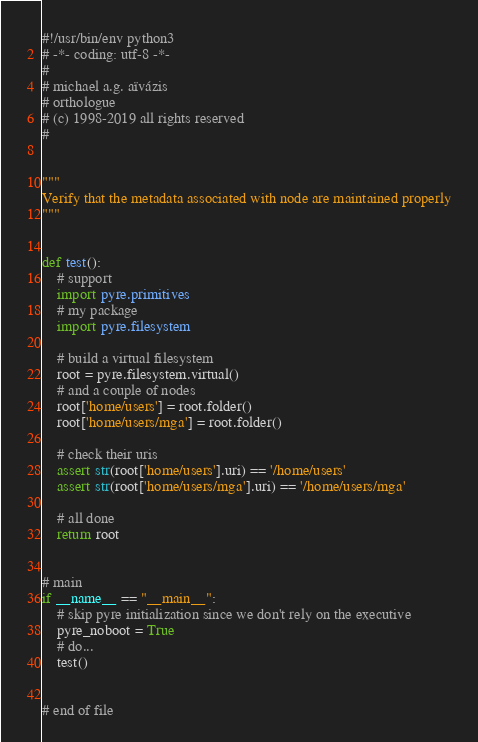<code> <loc_0><loc_0><loc_500><loc_500><_Python_>#!/usr/bin/env python3
# -*- coding: utf-8 -*-
#
# michael a.g. aïvázis
# orthologue
# (c) 1998-2019 all rights reserved
#


"""
Verify that the metadata associated with node are maintained properly
"""


def test():
    # support
    import pyre.primitives
    # my package
    import pyre.filesystem

    # build a virtual filesystem
    root = pyre.filesystem.virtual()
    # and a couple of nodes
    root['home/users'] = root.folder()
    root['home/users/mga'] = root.folder()

    # check their uris
    assert str(root['home/users'].uri) == '/home/users'
    assert str(root['home/users/mga'].uri) == '/home/users/mga'

    # all done
    return root


# main
if __name__ == "__main__":
    # skip pyre initialization since we don't rely on the executive
    pyre_noboot = True
    # do...
    test()


# end of file
</code> 